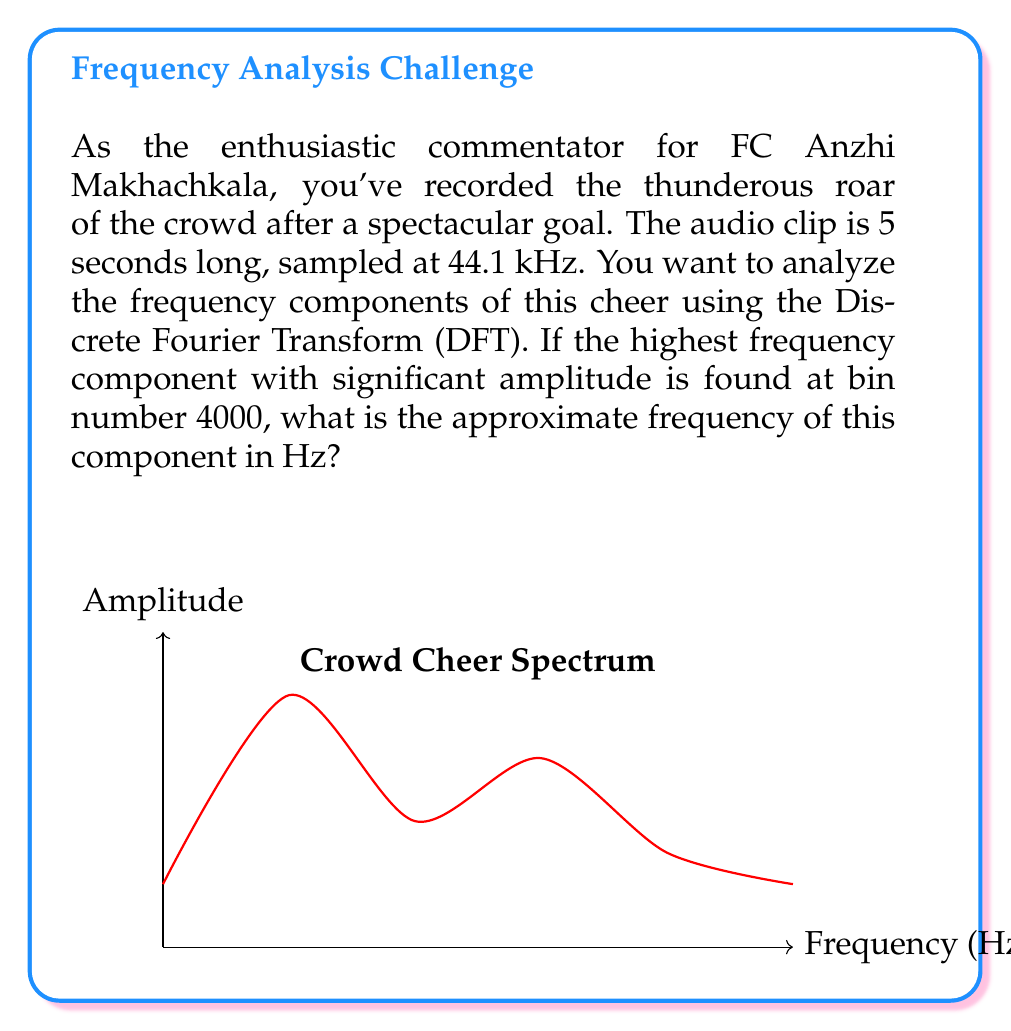What is the answer to this math problem? Let's approach this step-by-step:

1) The Discrete Fourier Transform (DFT) divides the frequency spectrum into N equally spaced bins, where N is the number of samples.

2) For a 5-second audio clip sampled at 44.1 kHz, the total number of samples is:
   $$N = 5 \text{ seconds} \times 44100 \text{ samples/second} = 220500 \text{ samples}$$

3) The frequency resolution of the DFT is given by:
   $$\Delta f = \frac{f_s}{N}$$
   where $f_s$ is the sampling frequency and $N$ is the number of samples.

4) Substituting our values:
   $$\Delta f = \frac{44100 \text{ Hz}}{220500} = 0.2 \text{ Hz}$$

5) The frequency corresponding to bin k is given by:
   $$f_k = k \times \Delta f$$

6) We're told the highest significant frequency component is at bin 4000. So:
   $$f_{4000} = 4000 \times 0.2 \text{ Hz} = 800 \text{ Hz}$$

Therefore, the approximate frequency of the highest significant component is 800 Hz.
Answer: 800 Hz 